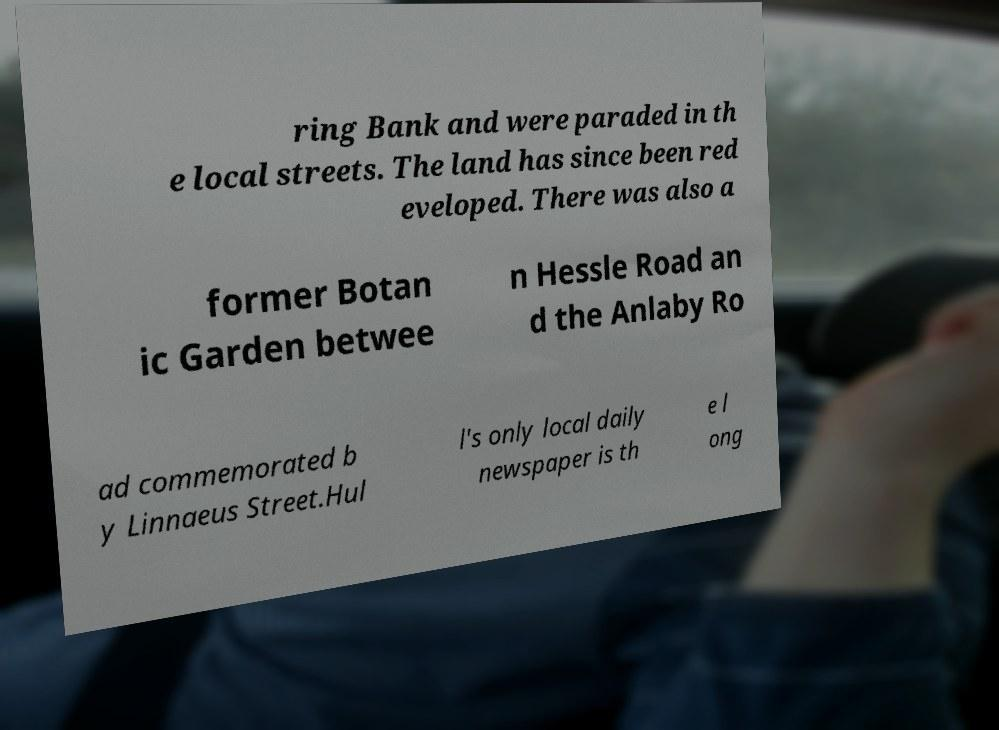I need the written content from this picture converted into text. Can you do that? ring Bank and were paraded in th e local streets. The land has since been red eveloped. There was also a former Botan ic Garden betwee n Hessle Road an d the Anlaby Ro ad commemorated b y Linnaeus Street.Hul l's only local daily newspaper is th e l ong 